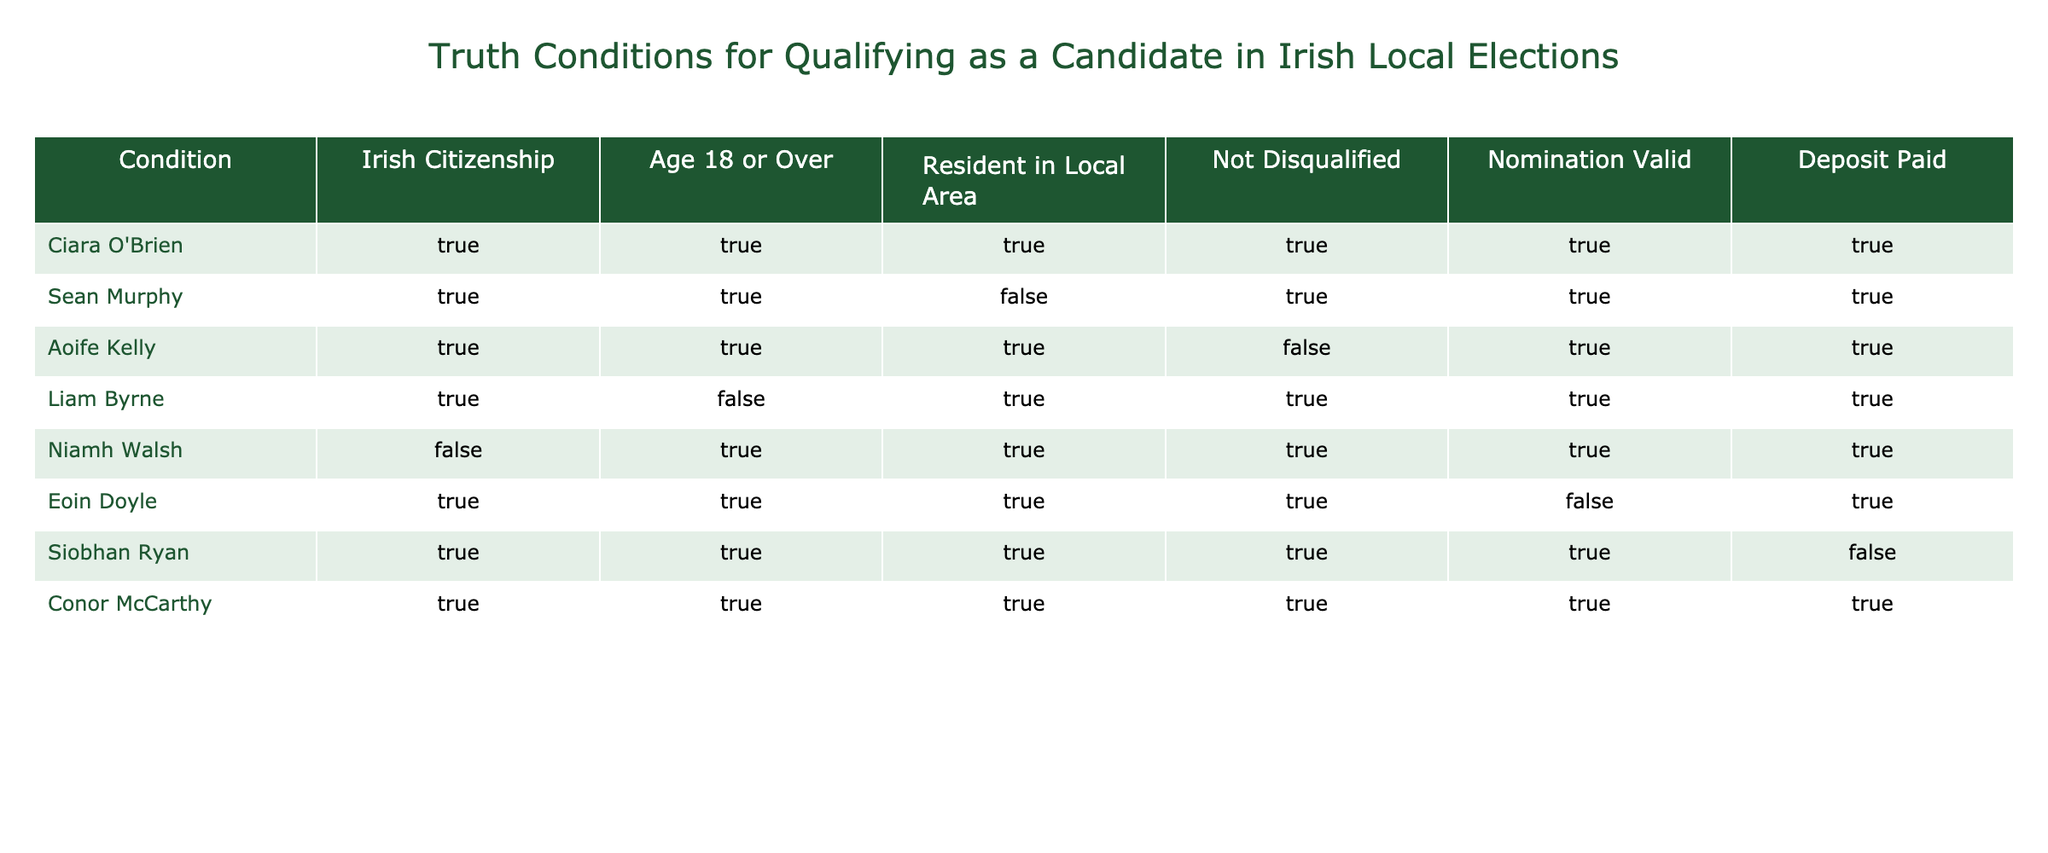What is the total number of candidates who are Irish citizens? By looking at the "Irish Citizenship" column, I can count the TRUE values. There are 7 candidates with Irish citizenship.
Answer: 7 Is Sean Murphy's nomination valid? Looking at the "Nomination Valid" column for Sean Murphy, it shows TRUE, indicating that his nomination is indeed valid.
Answer: Yes How many candidates are over the age of 18? By checking the "Age 18 or Over" column, there are 6 TRUE entries. Thus, 6 candidates are over the age of 18.
Answer: 6 Which candidate is the only one not disqualified? I review the "Not Disqualified" column and find that only Conor McCarthy has the TRUE value in that column, meaning he is the only candidate not disqualified.
Answer: Conor McCarthy Are there any candidates who are residents in the local area but have a disqualified nomination? I need to look at the "Resident in Local Area" for TRUE and "Not Disqualified" for FALSE. Among the candidates, I see that Aoife Kelly meets this condition, as she is a resident but not disqualified.
Answer: Yes What is the total number of candidates who paid the deposit? In the "Deposit Paid" column, I count how many candidates have TRUE values, which amounts to 6 candidates that paid the deposit.
Answer: 6 Which candidate is the only one listed without having a paid deposit? By examining the "Deposit Paid" column, I notice that Siobhan Ryan is the only candidate marked as FALSE, indicating she did not pay the deposit.
Answer: Siobhan Ryan If we consider only candidates aged over 18, how many are also qualified for nomination? First, I check the "Age 18 or Over" column for TRUE candidates, yielding 6 names. Next, I check how many of those have TRUE in "Nomination Valid," leading to 5 candidates qualified for nomination.
Answer: 5 Is there any candidate who fulfills all conditions but is not validly nominated? I review each candidate who has all conditions as TRUE but found that Eoin Doyle has a valid nomination marked FALSE, despite meeting the other conditions.
Answer: Yes 